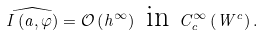Convert formula to latex. <formula><loc_0><loc_0><loc_500><loc_500>\widehat { I \left ( a , \varphi \right ) } = \mathcal { O } \left ( h ^ { \infty } \right ) \text { in } C _ { c } ^ { \infty } \left ( W ^ { c } \right ) .</formula> 